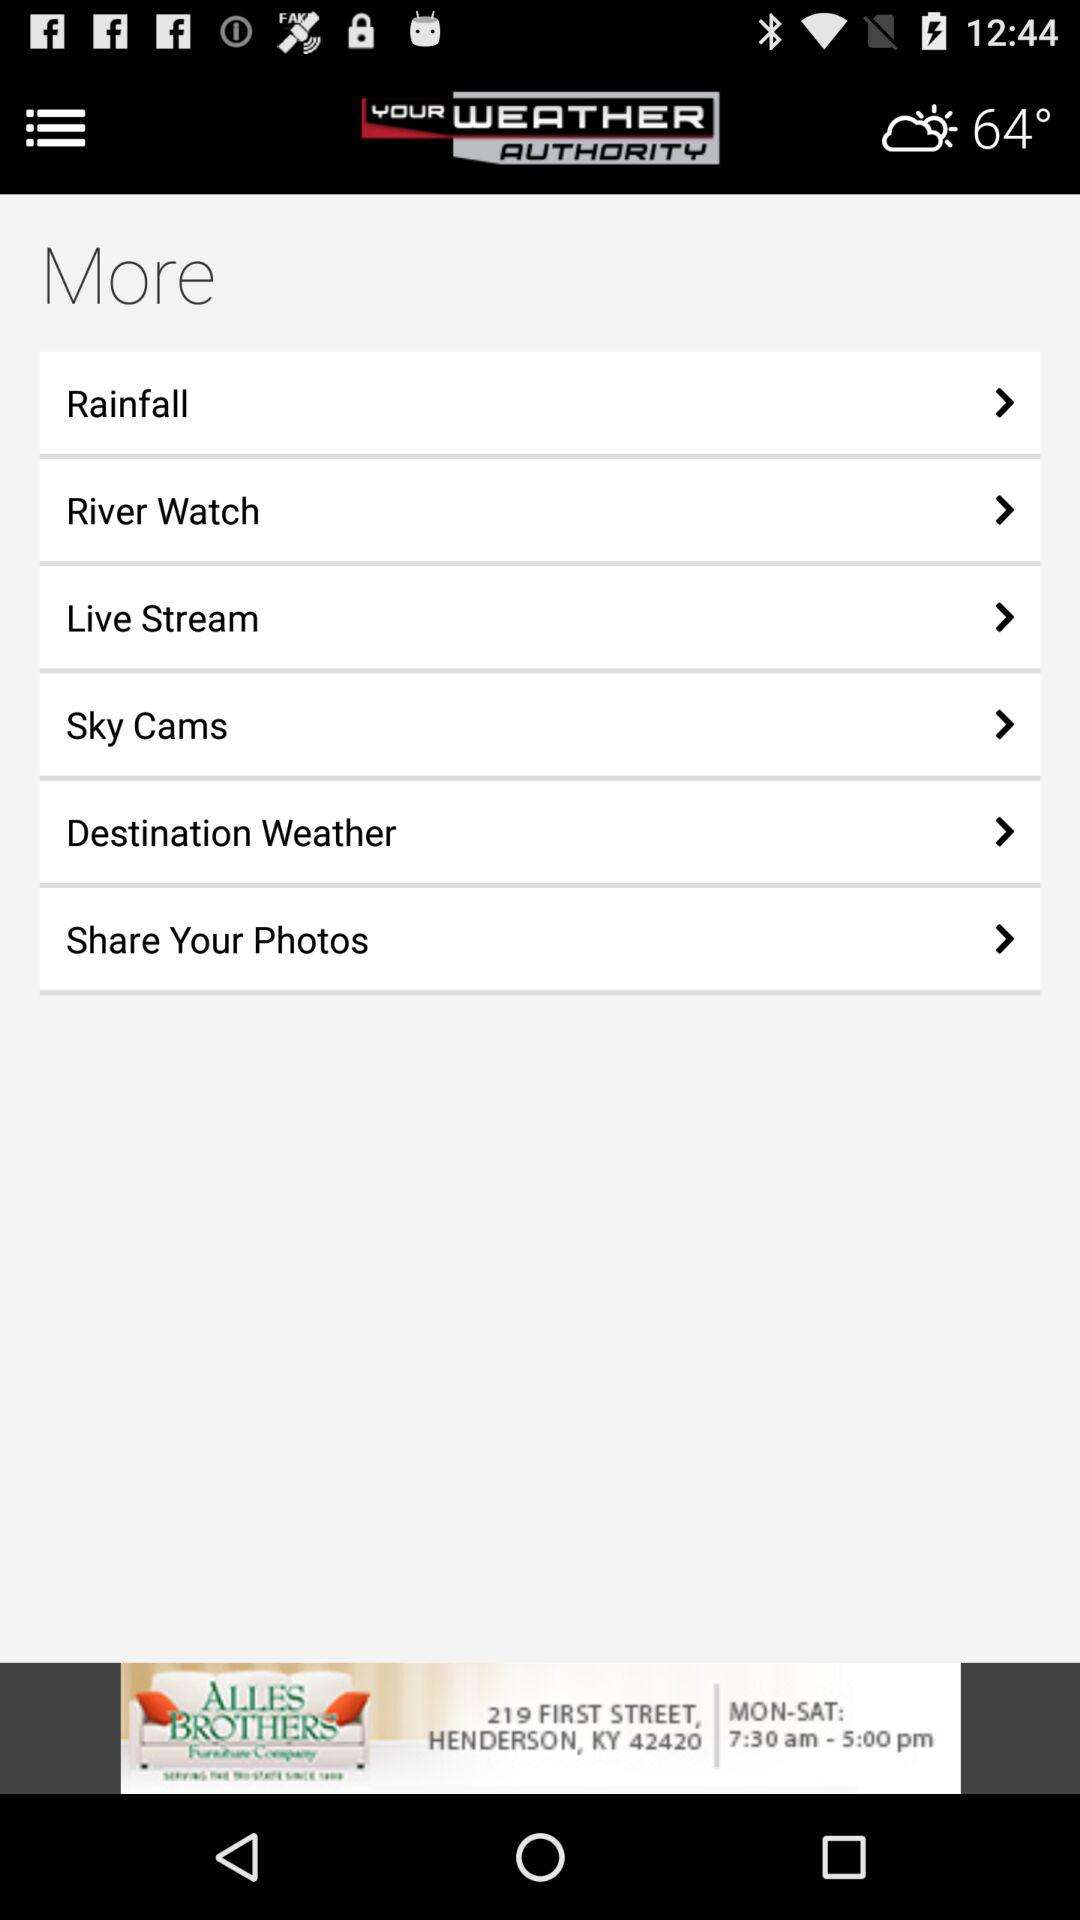What is the shown temperature? The shown temperature is 64°. 